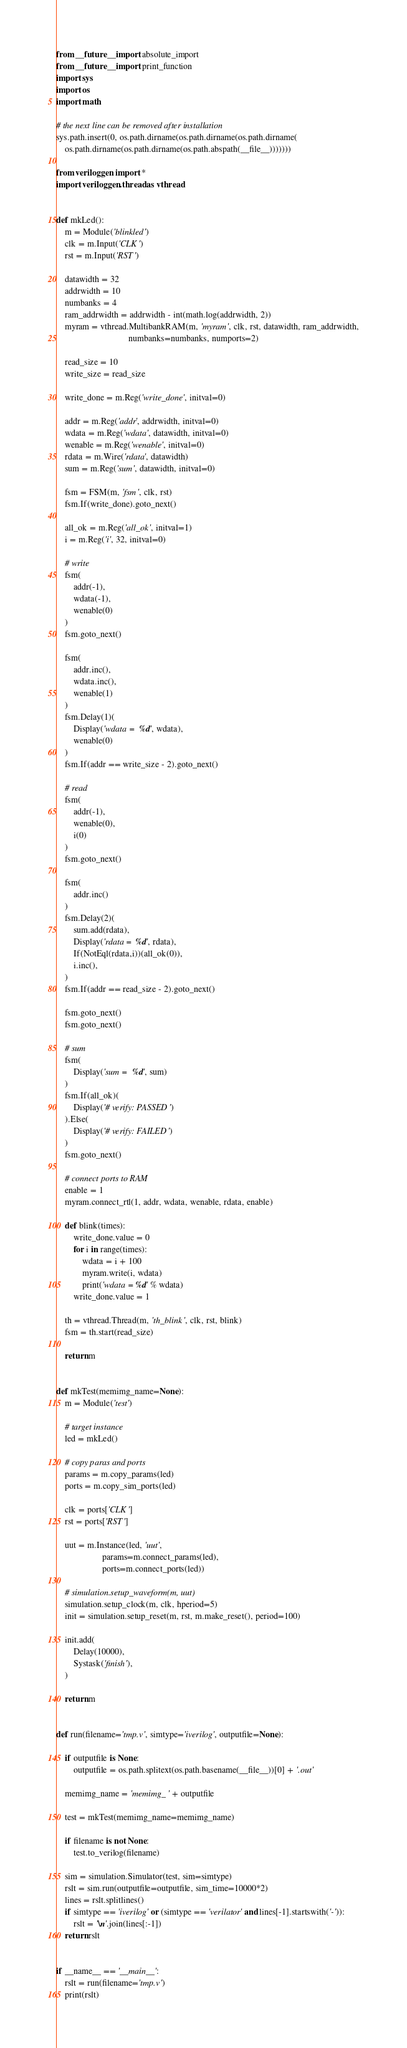<code> <loc_0><loc_0><loc_500><loc_500><_Python_>from __future__ import absolute_import
from __future__ import print_function
import sys
import os
import math

# the next line can be removed after installation
sys.path.insert(0, os.path.dirname(os.path.dirname(os.path.dirname(
    os.path.dirname(os.path.dirname(os.path.abspath(__file__)))))))

from veriloggen import *
import veriloggen.thread as vthread


def mkLed():
    m = Module('blinkled')
    clk = m.Input('CLK')
    rst = m.Input('RST')

    datawidth = 32
    addrwidth = 10
    numbanks = 4
    ram_addrwidth = addrwidth - int(math.log(addrwidth, 2))
    myram = vthread.MultibankRAM(m, 'myram', clk, rst, datawidth, ram_addrwidth,
                                 numbanks=numbanks, numports=2)

    read_size = 10
    write_size = read_size

    write_done = m.Reg('write_done', initval=0)

    addr = m.Reg('addr', addrwidth, initval=0)
    wdata = m.Reg('wdata', datawidth, initval=0)
    wenable = m.Reg('wenable', initval=0)
    rdata = m.Wire('rdata', datawidth)
    sum = m.Reg('sum', datawidth, initval=0)

    fsm = FSM(m, 'fsm', clk, rst)
    fsm.If(write_done).goto_next()

    all_ok = m.Reg('all_ok', initval=1)
    i = m.Reg('i', 32, initval=0)

    # write
    fsm(
        addr(-1),
        wdata(-1),
        wenable(0)
    )
    fsm.goto_next()

    fsm(
        addr.inc(),
        wdata.inc(),
        wenable(1)
    )
    fsm.Delay(1)(
        Display('wdata =  %d', wdata),
        wenable(0)
    )
    fsm.If(addr == write_size - 2).goto_next()

    # read
    fsm(
        addr(-1),
        wenable(0),
        i(0)
    )
    fsm.goto_next()

    fsm(
        addr.inc()
    )
    fsm.Delay(2)(
        sum.add(rdata),
        Display('rdata =  %d', rdata),
        If(NotEql(rdata,i))(all_ok(0)),
        i.inc(),
    )
    fsm.If(addr == read_size - 2).goto_next()

    fsm.goto_next()
    fsm.goto_next()

    # sum
    fsm(
        Display('sum =  %d', sum)
    )
    fsm.If(all_ok)(
        Display('# verify: PASSED')
    ).Else(
        Display('# verify: FAILED')
    )
    fsm.goto_next()

    # connect ports to RAM
    enable = 1
    myram.connect_rtl(1, addr, wdata, wenable, rdata, enable)

    def blink(times):
        write_done.value = 0
        for i in range(times):
            wdata = i + 100
            myram.write(i, wdata)
            print('wdata = %d' % wdata)
        write_done.value = 1

    th = vthread.Thread(m, 'th_blink', clk, rst, blink)
    fsm = th.start(read_size)

    return m


def mkTest(memimg_name=None):
    m = Module('test')

    # target instance
    led = mkLed()

    # copy paras and ports
    params = m.copy_params(led)
    ports = m.copy_sim_ports(led)

    clk = ports['CLK']
    rst = ports['RST']

    uut = m.Instance(led, 'uut',
                     params=m.connect_params(led),
                     ports=m.connect_ports(led))

    # simulation.setup_waveform(m, uut)
    simulation.setup_clock(m, clk, hperiod=5)
    init = simulation.setup_reset(m, rst, m.make_reset(), period=100)

    init.add(
        Delay(10000),
        Systask('finish'),
    )

    return m


def run(filename='tmp.v', simtype='iverilog', outputfile=None):

    if outputfile is None:
        outputfile = os.path.splitext(os.path.basename(__file__))[0] + '.out'

    memimg_name = 'memimg_' + outputfile

    test = mkTest(memimg_name=memimg_name)

    if filename is not None:
        test.to_verilog(filename)

    sim = simulation.Simulator(test, sim=simtype)
    rslt = sim.run(outputfile=outputfile, sim_time=10000*2)
    lines = rslt.splitlines()
    if simtype == 'iverilog' or (simtype == 'verilator' and lines[-1].startswith('-')):
        rslt = '\n'.join(lines[:-1])
    return rslt


if __name__ == '__main__':
    rslt = run(filename='tmp.v')
    print(rslt)
</code> 